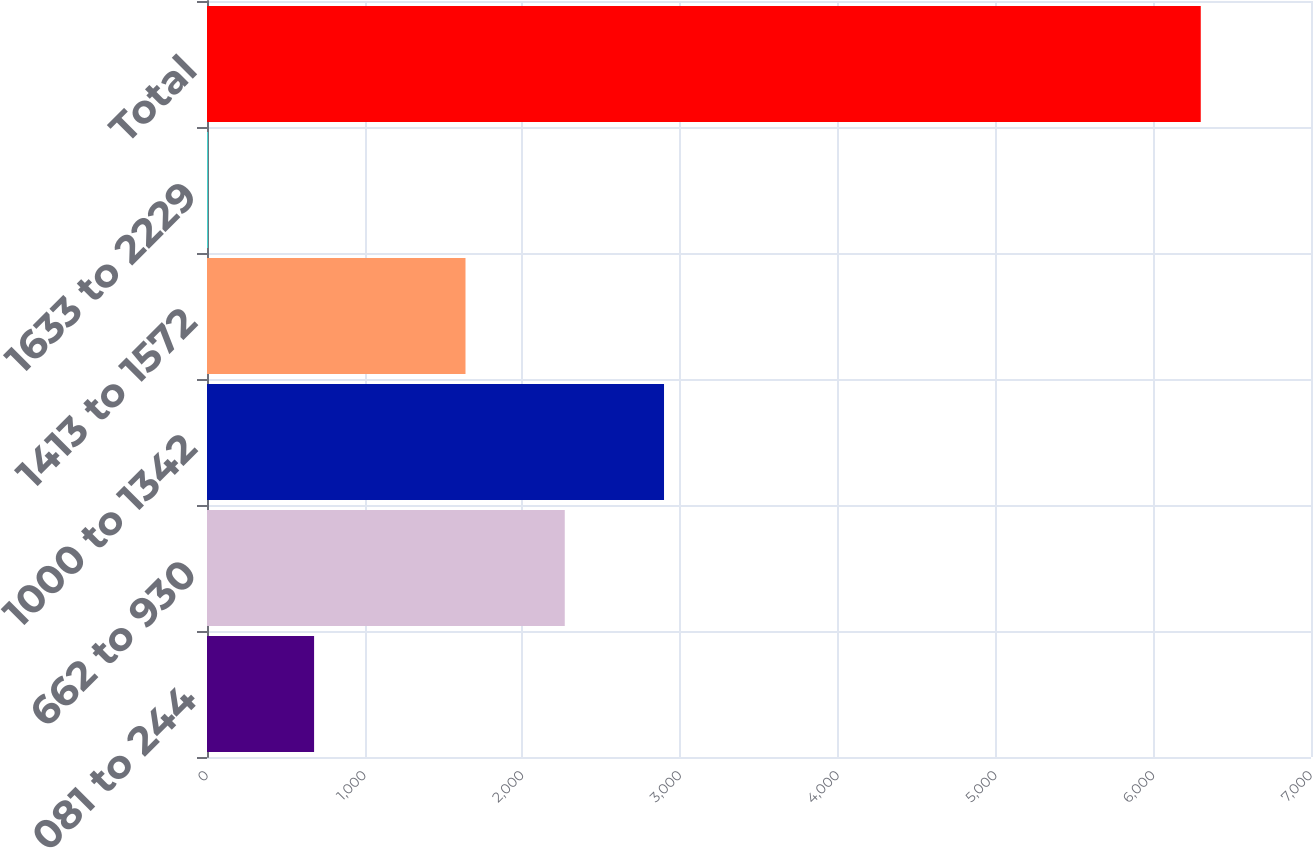<chart> <loc_0><loc_0><loc_500><loc_500><bar_chart><fcel>081 to 244<fcel>662 to 930<fcel>1000 to 1342<fcel>1413 to 1572<fcel>1633 to 2229<fcel>Total<nl><fcel>679<fcel>2268.4<fcel>2897.8<fcel>1639<fcel>7<fcel>6301<nl></chart> 